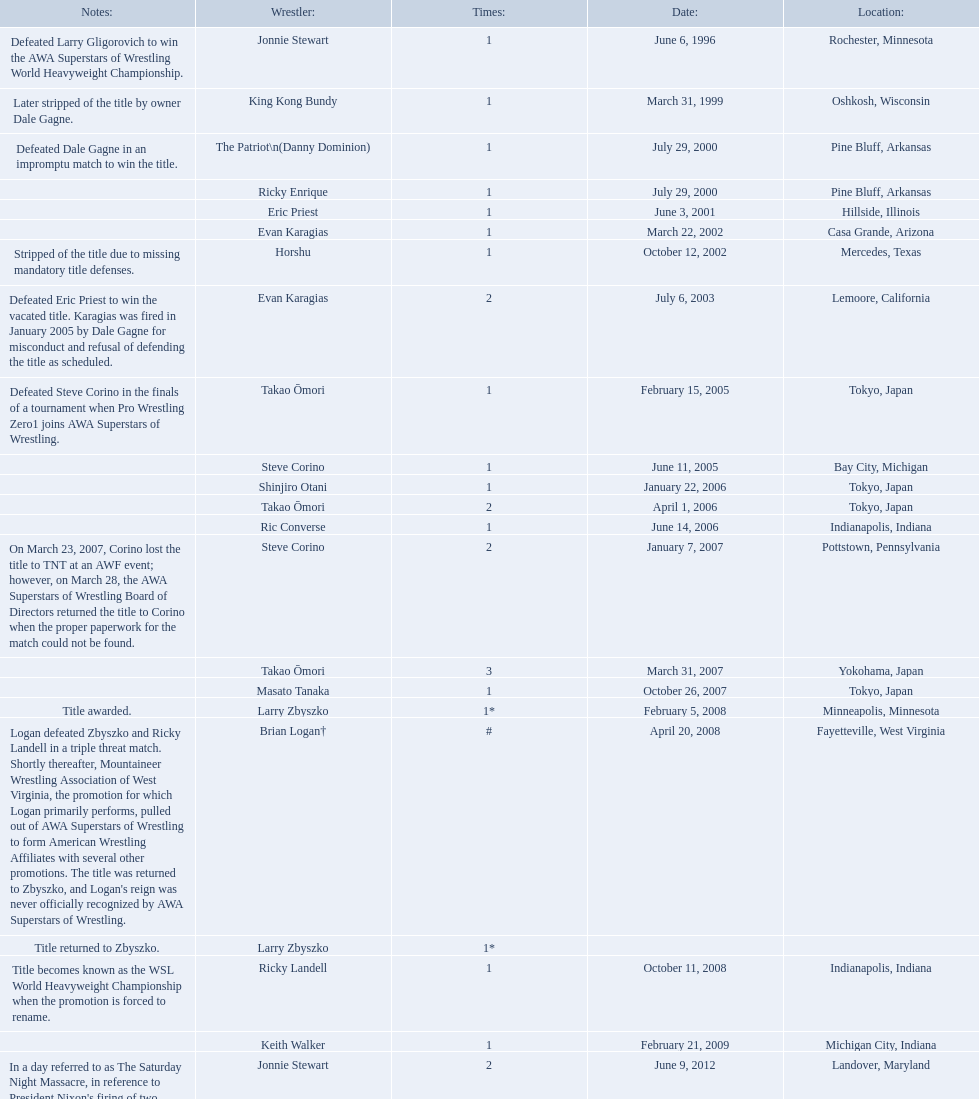How many times has ricky landell held the wsl title? 1. 